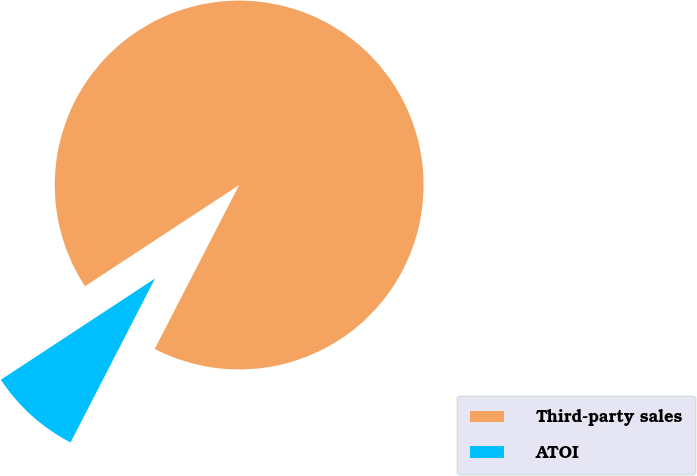Convert chart to OTSL. <chart><loc_0><loc_0><loc_500><loc_500><pie_chart><fcel>Third-party sales<fcel>ATOI<nl><fcel>91.82%<fcel>8.18%<nl></chart> 